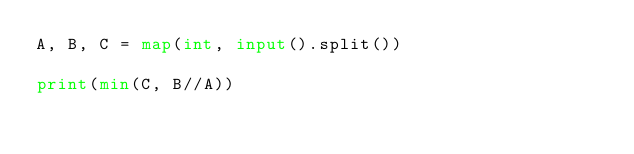Convert code to text. <code><loc_0><loc_0><loc_500><loc_500><_Python_>A, B, C = map(int, input().split())

print(min(C, B//A))</code> 